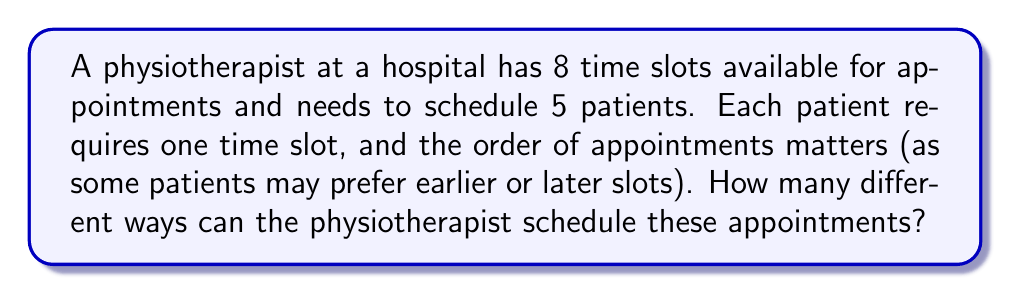Can you solve this math problem? Let's approach this step-by-step:

1) This is a permutation problem. We are selecting 5 slots out of 8 available slots, and the order matters.

2) In permutation problems where order matters and we're selecting r items from n total items, we use the formula:

   $P(n,r) = \frac{n!}{(n-r)!}$

3) In this case, n = 8 (total time slots) and r = 5 (patients to be scheduled)

4) Plugging these values into our formula:

   $P(8,5) = \frac{8!}{(8-5)!} = \frac{8!}{3!}$

5) Let's calculate this:
   
   $$\begin{align}
   P(8,5) &= \frac{8 \times 7 \times 6 \times 5 \times 4 \times 3!}{3!} \\
   &= 8 \times 7 \times 6 \times 5 \times 4 \\
   &= 6720
   \end{align}$$

6) Therefore, there are 6720 different ways to schedule the appointments.

This large number reflects the many possibilities the physiotherapist has in arranging these appointments, allowing for flexibility in accommodating patient preferences and hospital constraints.
Answer: 6720 